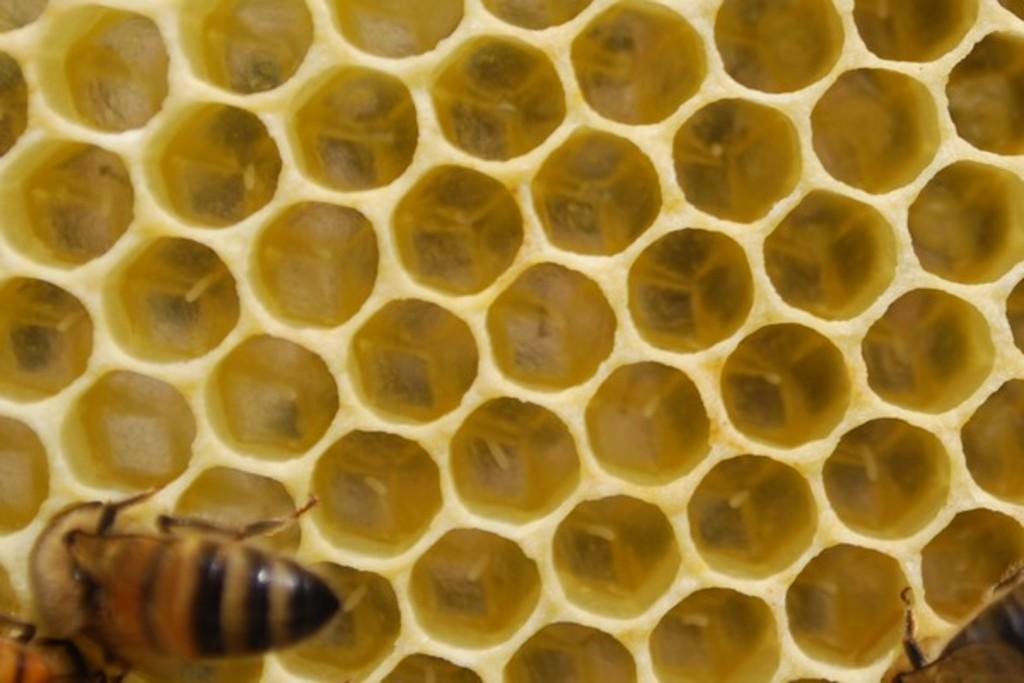What type of insects are present in the image? There are honey bees in the image. What are the honey bees situated on? The honey bees are on a honeycomb. What type of arm is visible in the image? There is no arm present in the image; it features honey bees on a honeycomb. What type of test is being conducted in the image? There is no test being conducted in the image; it features honey bees on a honeycomb. 